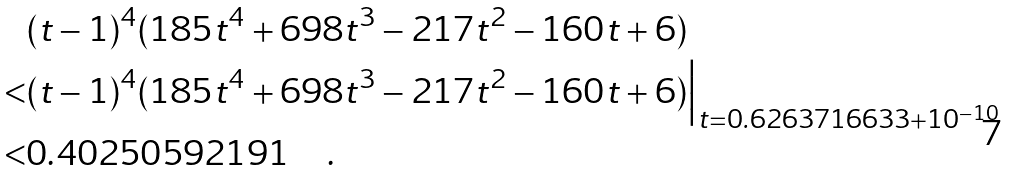Convert formula to latex. <formula><loc_0><loc_0><loc_500><loc_500>& ( t - 1 ) ^ { 4 } ( 1 8 5 t ^ { 4 } + 6 9 8 t ^ { 3 } - 2 1 7 t ^ { 2 } - 1 6 0 t + 6 ) \\ < & ( t - 1 ) ^ { 4 } ( 1 8 5 t ^ { 4 } + 6 9 8 t ^ { 3 } - 2 1 7 t ^ { 2 } - 1 6 0 t + 6 ) \Big | _ { t = 0 . 6 2 6 3 7 1 6 6 3 3 + 1 0 ^ { - 1 0 } } \\ < & 0 . 4 0 2 5 0 5 9 2 1 9 1 \quad .</formula> 